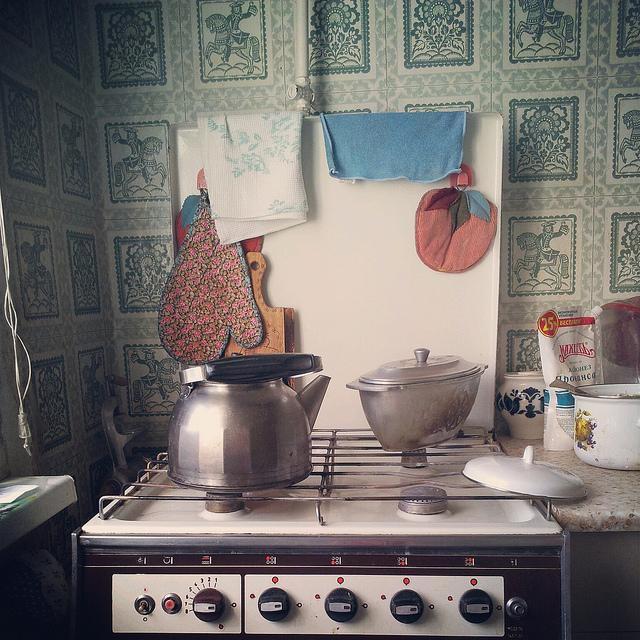How many pins are on the stove?
Give a very brief answer. 0. How many bowls can be seen?
Give a very brief answer. 2. 